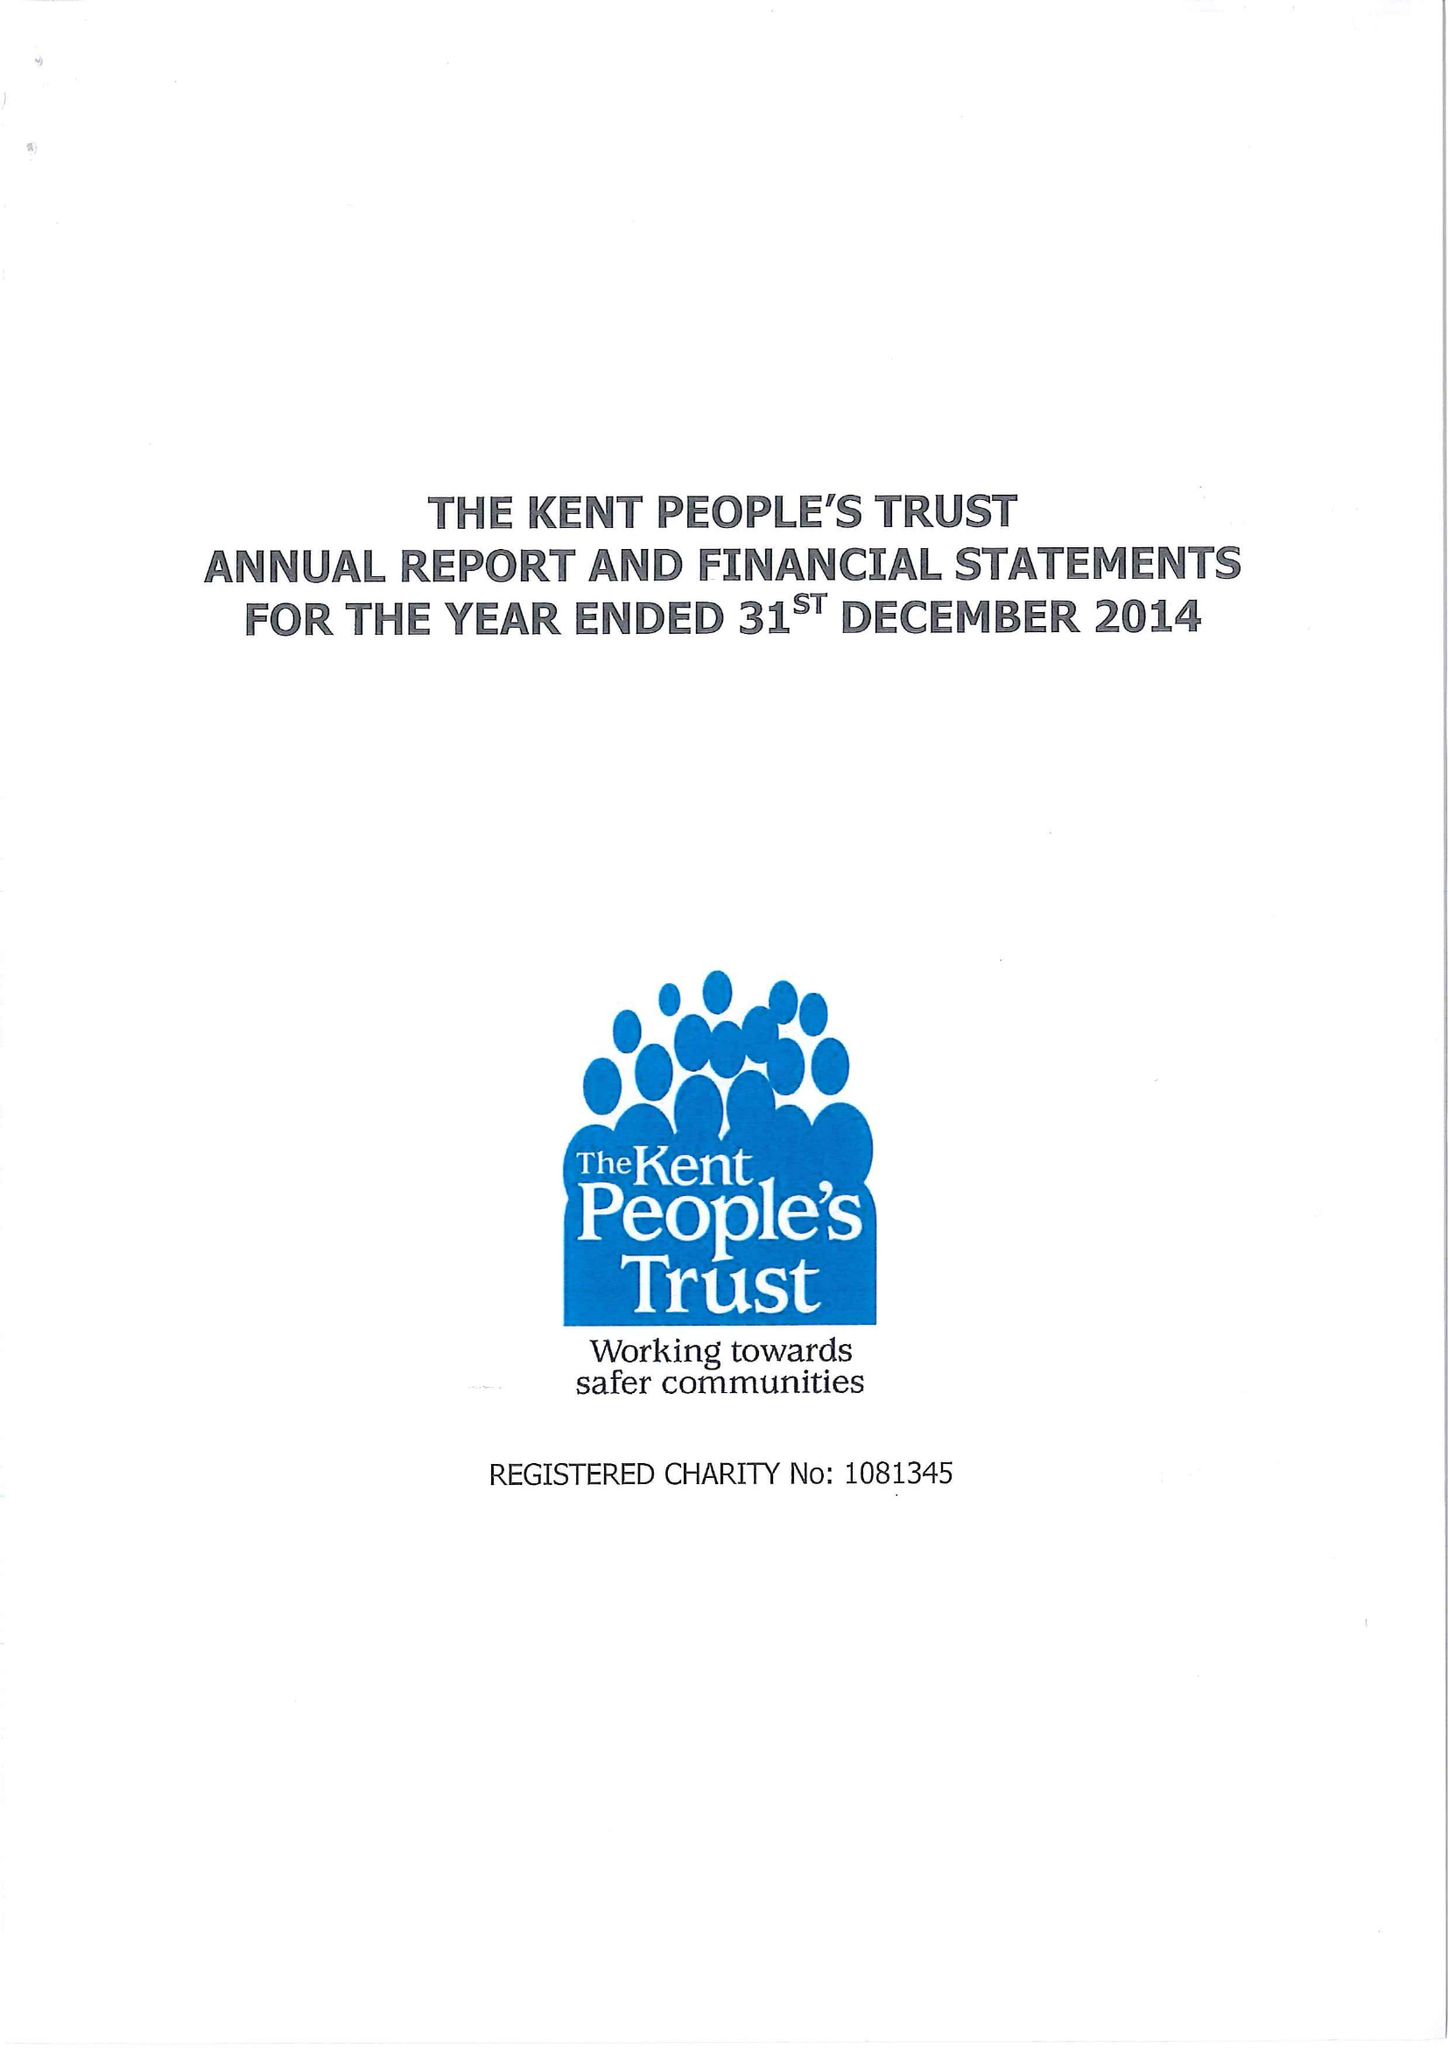What is the value for the report_date?
Answer the question using a single word or phrase. 2014-12-31 